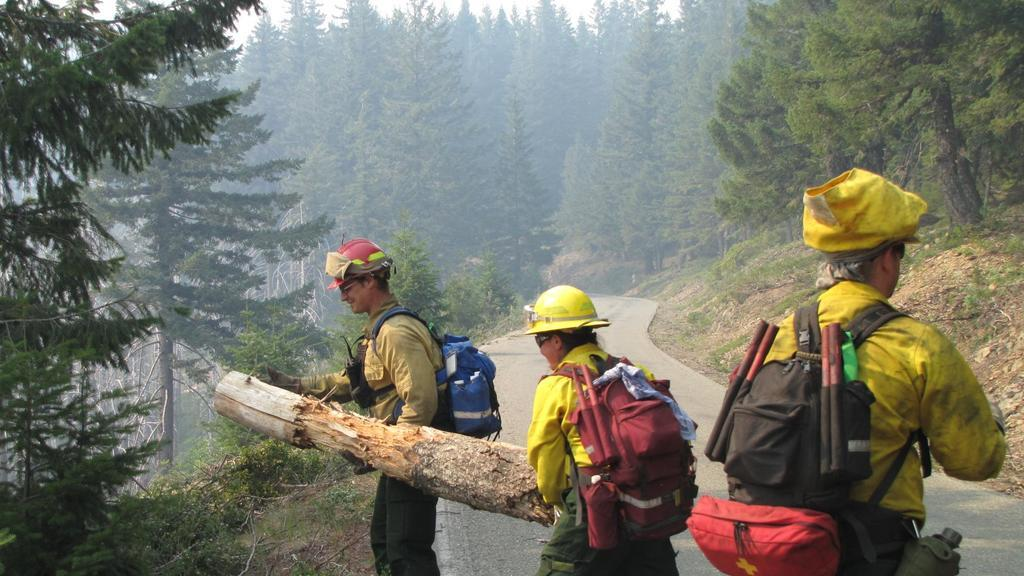How many people are present in the image? There are three people in the image. What are the people wearing in the image? The three people are wearing bags. What are two of the people holding in the image? Two people are holding a wooden log. What can be seen in the background of the image? There are trees in the background of the image. Reasoning: Let' Let's think step by step in order to produce the conversation. We start by identifying the number of people in the image, which is three. Then, we describe what the people are wearing, which are bags. Next, we focus on the actions of the people, noting that two of them are holding a wooden log. Finally, we describe the background of the image, which includes trees. Absurd Question/Answer: What type of skin can be seen on the wooden log in the image? There is no skin visible on the wooden log in the image, as it is an inanimate object made of wood. 